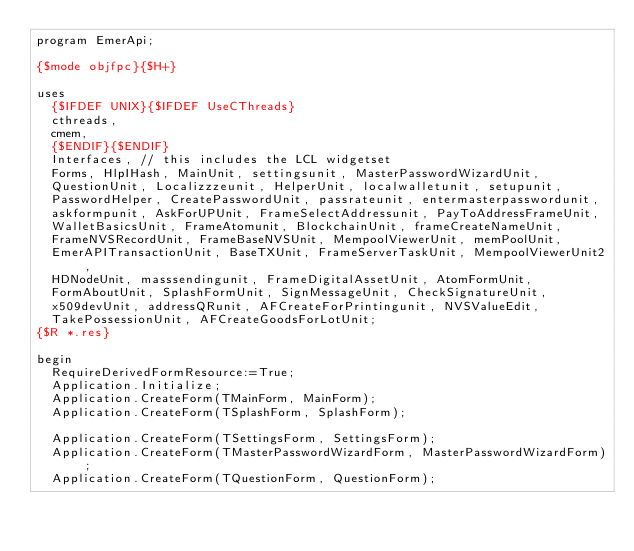<code> <loc_0><loc_0><loc_500><loc_500><_Pascal_>program EmerApi;

{$mode objfpc}{$H+}

uses
  {$IFDEF UNIX}{$IFDEF UseCThreads}
  cthreads,
  cmem,
  {$ENDIF}{$ENDIF}
  Interfaces, // this includes the LCL widgetset
  Forms, HlpIHash, MainUnit, settingsunit, MasterPasswordWizardUnit,
  QuestionUnit, Localizzzeunit, HelperUnit, localwalletunit, setupunit,
  PasswordHelper, CreatePasswordUnit, passrateunit, entermasterpasswordunit,
  askformpunit, AskForUPUnit, FrameSelectAddressunit, PayToAddressFrameUnit,
  WalletBasicsUnit, FrameAtomunit, BlockchainUnit, frameCreateNameUnit,
  FrameNVSRecordUnit, FrameBaseNVSUnit, MempoolViewerUnit, memPoolUnit,
  EmerAPITransactionUnit, BaseTXUnit, FrameServerTaskUnit, MempoolViewerUnit2,
  HDNodeUnit, masssendingunit, FrameDigitalAssetUnit, AtomFormUnit,
  FormAboutUnit, SplashFormUnit, SignMessageUnit, CheckSignatureUnit,
  x509devUnit, addressQRunit, AFCreateForPrintingunit, NVSValueEdit,
  TakePossessionUnit, AFCreateGoodsForLotUnit;
{$R *.res}

begin
  RequireDerivedFormResource:=True;
  Application.Initialize;
  Application.CreateForm(TMainForm, MainForm);
  Application.CreateForm(TSplashForm, SplashForm);

  Application.CreateForm(TSettingsForm, SettingsForm);
  Application.CreateForm(TMasterPasswordWizardForm, MasterPasswordWizardForm);
  Application.CreateForm(TQuestionForm, QuestionForm);</code> 